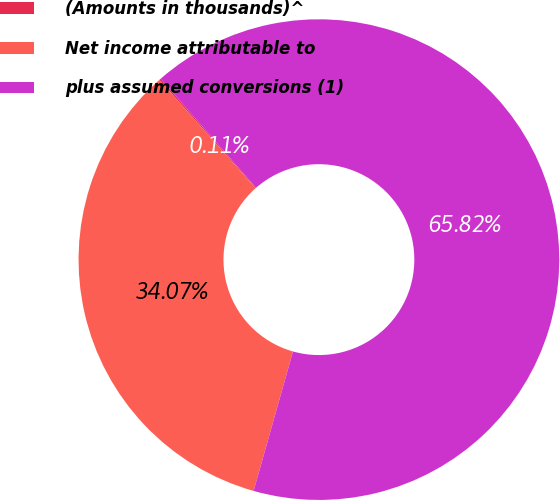Convert chart. <chart><loc_0><loc_0><loc_500><loc_500><pie_chart><fcel>(Amounts in thousands)^<fcel>Net income attributable to<fcel>plus assumed conversions (1)<nl><fcel>0.11%<fcel>34.07%<fcel>65.82%<nl></chart> 